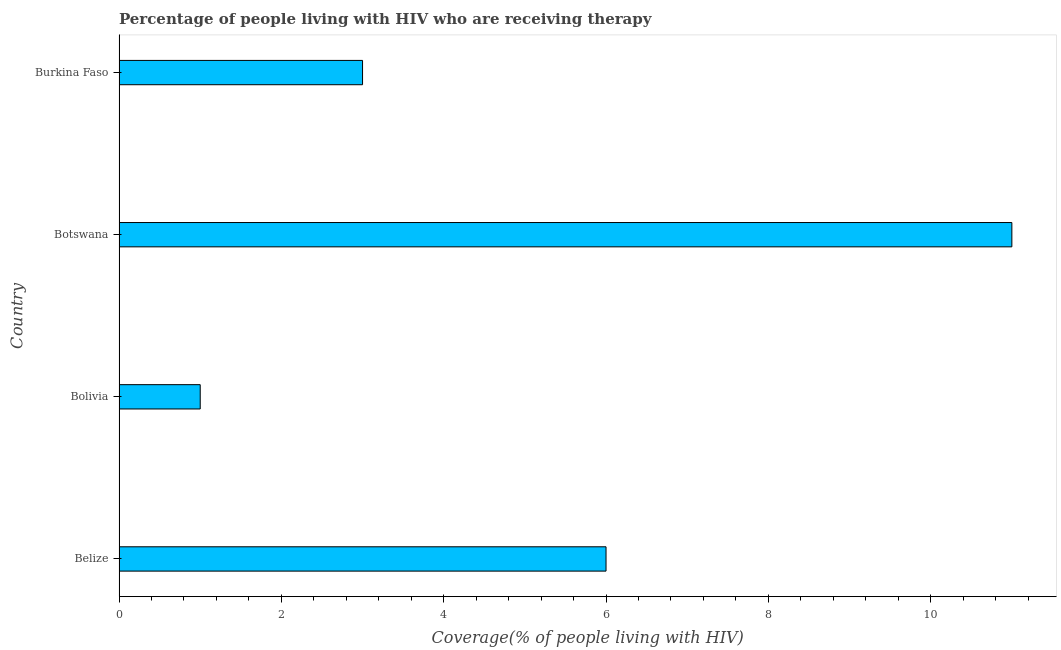Does the graph contain grids?
Make the answer very short. No. What is the title of the graph?
Provide a succinct answer. Percentage of people living with HIV who are receiving therapy. What is the label or title of the X-axis?
Offer a very short reply. Coverage(% of people living with HIV). What is the label or title of the Y-axis?
Offer a very short reply. Country. Across all countries, what is the minimum antiretroviral therapy coverage?
Keep it short and to the point. 1. In which country was the antiretroviral therapy coverage maximum?
Offer a very short reply. Botswana. What is the average antiretroviral therapy coverage per country?
Ensure brevity in your answer.  5.25. What is the median antiretroviral therapy coverage?
Your response must be concise. 4.5. What is the ratio of the antiretroviral therapy coverage in Belize to that in Botswana?
Make the answer very short. 0.55. Is the antiretroviral therapy coverage in Belize less than that in Burkina Faso?
Your response must be concise. No. Is the difference between the antiretroviral therapy coverage in Belize and Botswana greater than the difference between any two countries?
Make the answer very short. No. Is the sum of the antiretroviral therapy coverage in Bolivia and Burkina Faso greater than the maximum antiretroviral therapy coverage across all countries?
Make the answer very short. No. What is the difference between the highest and the lowest antiretroviral therapy coverage?
Offer a terse response. 10. In how many countries, is the antiretroviral therapy coverage greater than the average antiretroviral therapy coverage taken over all countries?
Make the answer very short. 2. What is the difference between two consecutive major ticks on the X-axis?
Offer a very short reply. 2. What is the Coverage(% of people living with HIV) in Bolivia?
Give a very brief answer. 1. What is the difference between the Coverage(% of people living with HIV) in Belize and Bolivia?
Offer a terse response. 5. What is the difference between the Coverage(% of people living with HIV) in Belize and Botswana?
Provide a succinct answer. -5. What is the ratio of the Coverage(% of people living with HIV) in Belize to that in Botswana?
Ensure brevity in your answer.  0.55. What is the ratio of the Coverage(% of people living with HIV) in Bolivia to that in Botswana?
Offer a terse response. 0.09. What is the ratio of the Coverage(% of people living with HIV) in Bolivia to that in Burkina Faso?
Ensure brevity in your answer.  0.33. What is the ratio of the Coverage(% of people living with HIV) in Botswana to that in Burkina Faso?
Your answer should be very brief. 3.67. 